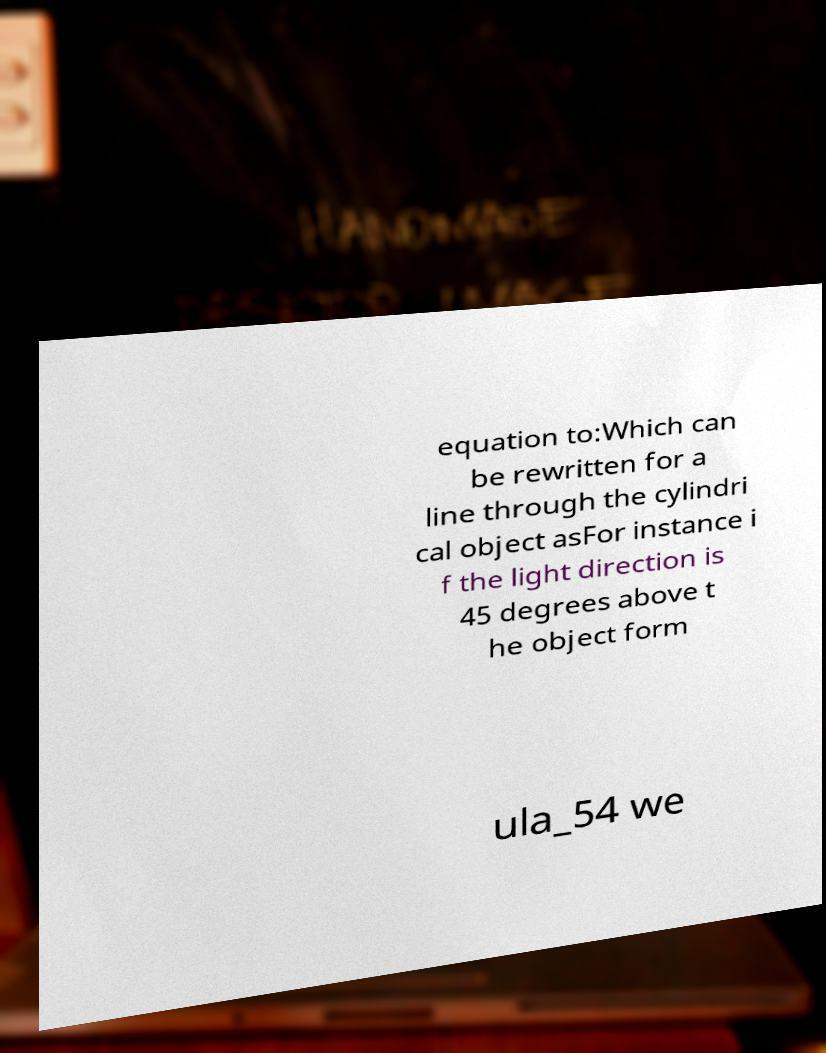I need the written content from this picture converted into text. Can you do that? equation to:Which can be rewritten for a line through the cylindri cal object asFor instance i f the light direction is 45 degrees above t he object form ula_54 we 